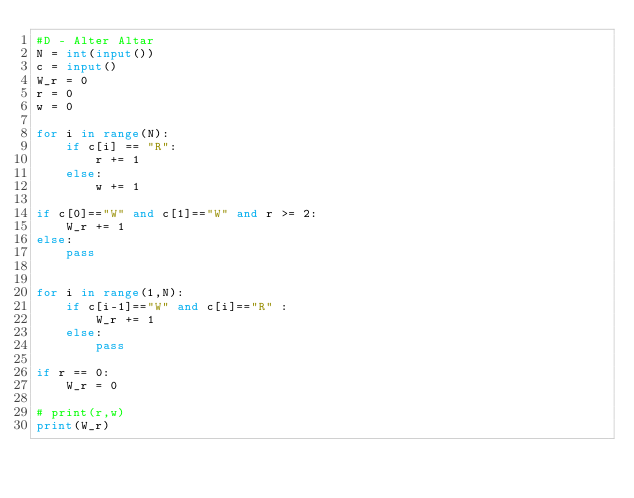<code> <loc_0><loc_0><loc_500><loc_500><_Python_>#D - Alter Altar
N = int(input())
c = input()
W_r = 0
r = 0
w = 0

for i in range(N):
    if c[i] == "R":
        r += 1
    else:
        w += 1

if c[0]=="W" and c[1]=="W" and r >= 2:
    W_r += 1
else:
    pass


for i in range(1,N):
    if c[i-1]=="W" and c[i]=="R" :
        W_r += 1
    else:
        pass

if r == 0:
    W_r = 0

# print(r,w)
print(W_r)</code> 